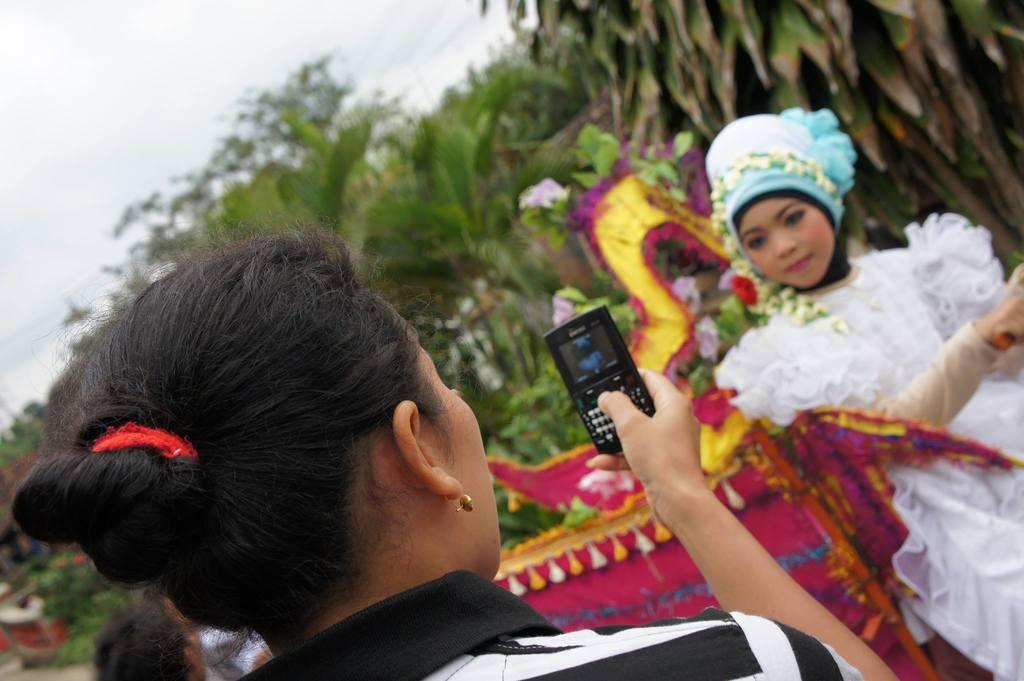Who is the main subject in the image? There is a woman in the image. What is the woman doing in the image? The woman is taking a photograph of another woman. What is the woman being photographed doing? The woman being photographed is posing for the photo. What is the woman being photographed wearing? The woman being photographed is wearing a white dress. What can be seen in the background of the image? There are trees and clouds visible in the background of the image. What type of parcel is being used as bait in the image? There is no parcel or bait present in the image. What type of loaf is being held by the woman in the image? There is no loaf visible in the image; the woman is holding a camera to take a photograph. 